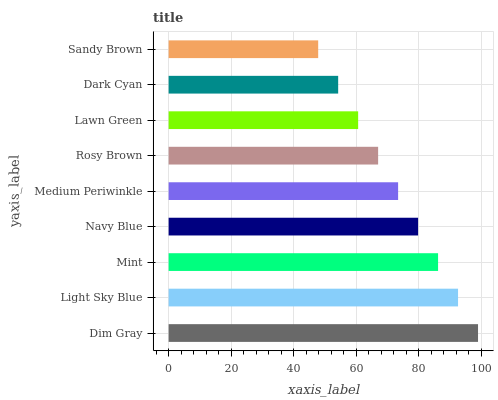Is Sandy Brown the minimum?
Answer yes or no. Yes. Is Dim Gray the maximum?
Answer yes or no. Yes. Is Light Sky Blue the minimum?
Answer yes or no. No. Is Light Sky Blue the maximum?
Answer yes or no. No. Is Dim Gray greater than Light Sky Blue?
Answer yes or no. Yes. Is Light Sky Blue less than Dim Gray?
Answer yes or no. Yes. Is Light Sky Blue greater than Dim Gray?
Answer yes or no. No. Is Dim Gray less than Light Sky Blue?
Answer yes or no. No. Is Medium Periwinkle the high median?
Answer yes or no. Yes. Is Medium Periwinkle the low median?
Answer yes or no. Yes. Is Dim Gray the high median?
Answer yes or no. No. Is Sandy Brown the low median?
Answer yes or no. No. 